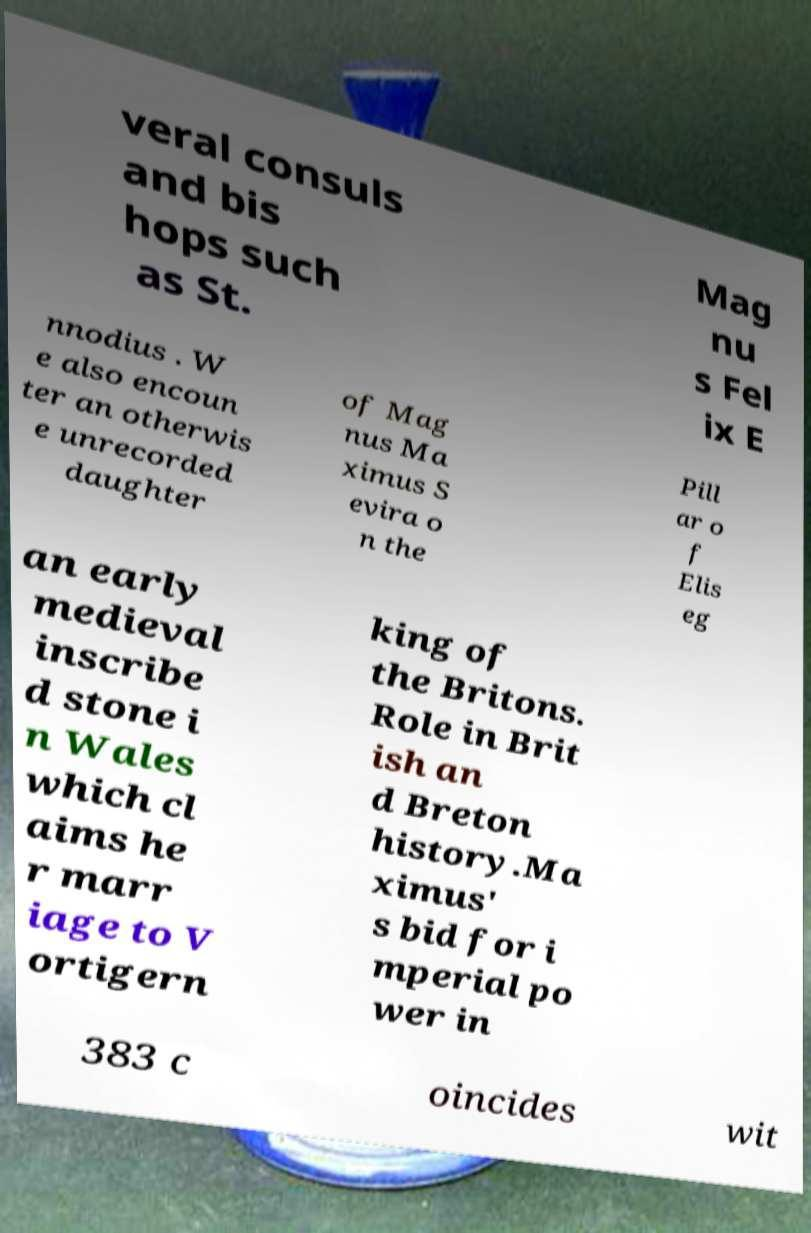Please read and relay the text visible in this image. What does it say? veral consuls and bis hops such as St. Mag nu s Fel ix E nnodius . W e also encoun ter an otherwis e unrecorded daughter of Mag nus Ma ximus S evira o n the Pill ar o f Elis eg an early medieval inscribe d stone i n Wales which cl aims he r marr iage to V ortigern king of the Britons. Role in Brit ish an d Breton history.Ma ximus' s bid for i mperial po wer in 383 c oincides wit 